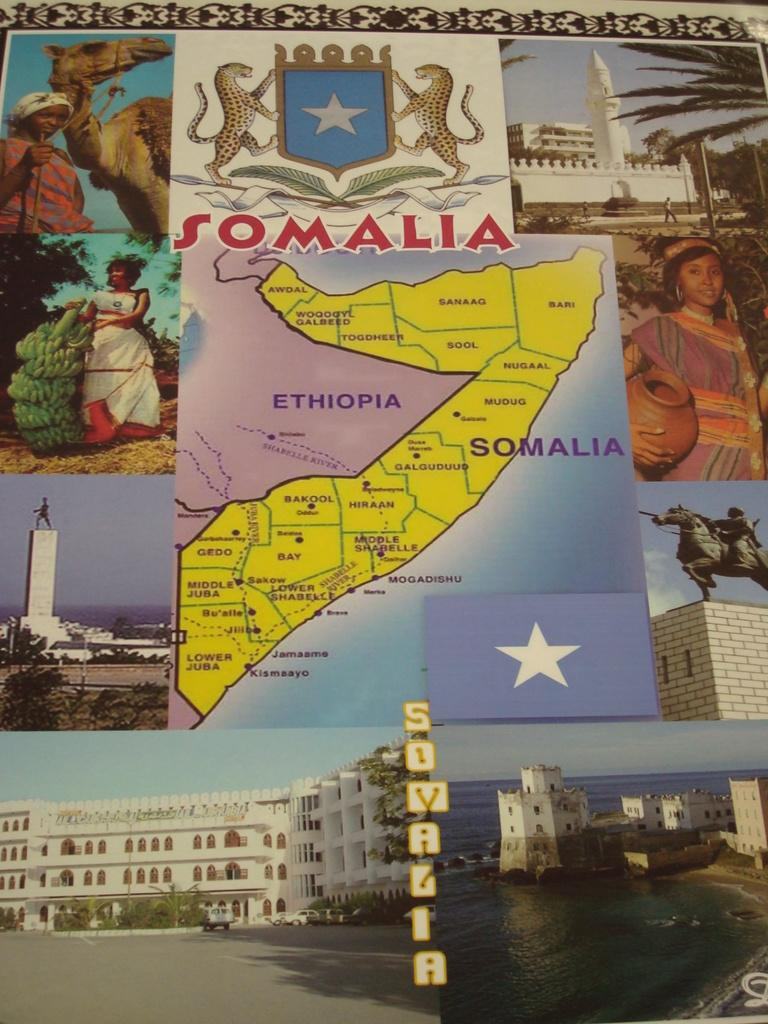<image>
Share a concise interpretation of the image provided. Map of Somalia surrounded by artwork, coat of arms, and flag. 